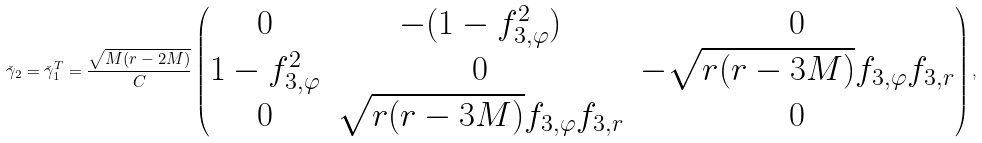Convert formula to latex. <formula><loc_0><loc_0><loc_500><loc_500>\check { \gamma } _ { 2 } = \check { \gamma } _ { 1 } ^ { T } = \frac { \sqrt { M ( r - 2 M ) } } { C } \begin{pmatrix} 0 & - ( 1 - f _ { 3 , \varphi } ^ { 2 } ) & 0 \\ 1 - f _ { 3 , \varphi } ^ { 2 } & 0 & - \sqrt { r ( r - 3 M ) } f _ { 3 , \varphi } f _ { 3 , r } \\ 0 & \sqrt { r ( r - 3 M ) } f _ { 3 , \varphi } f _ { 3 , r } & 0 \end{pmatrix} ,</formula> 